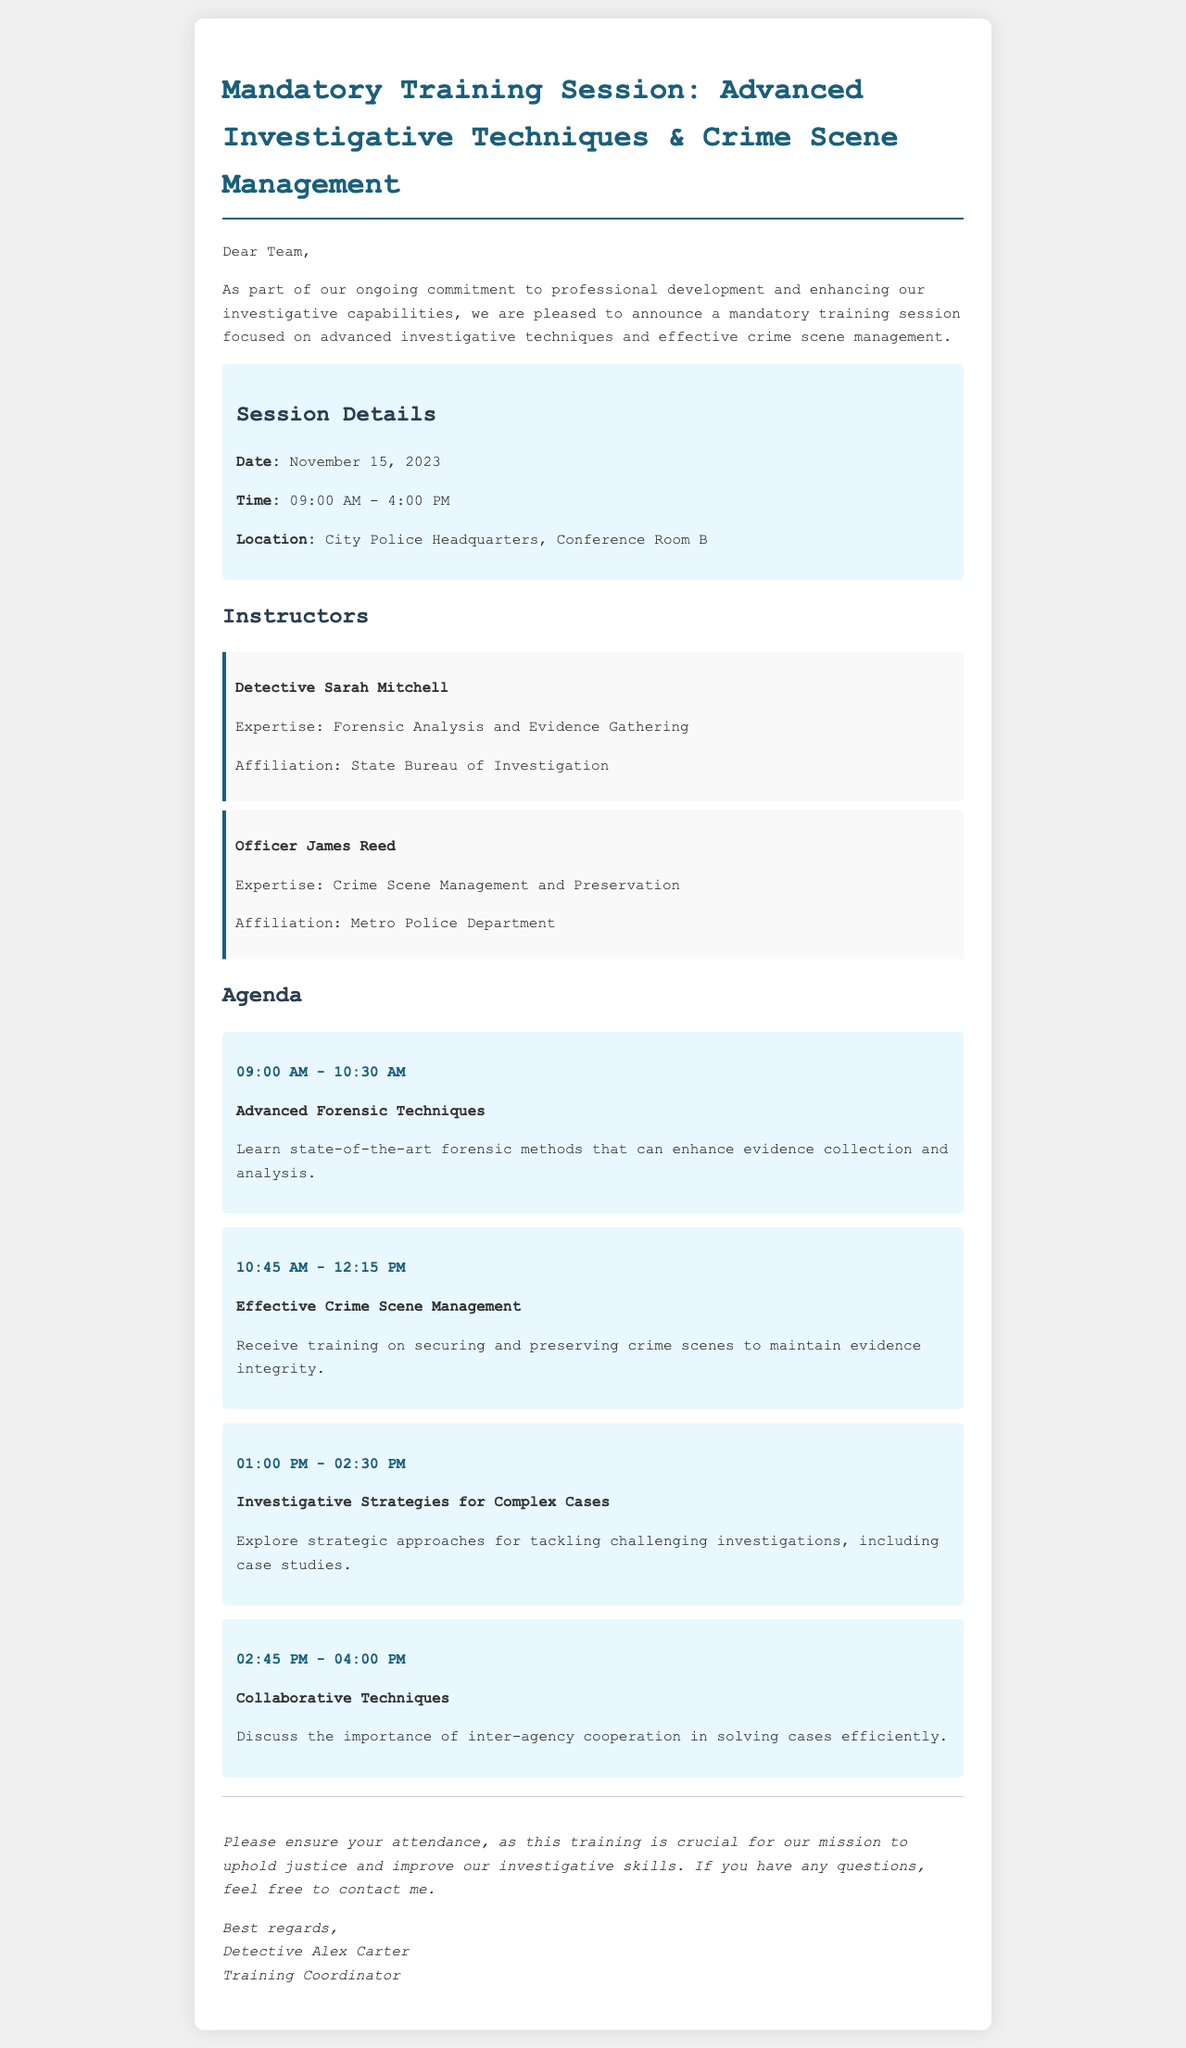What is the date of the training session? The date is mentioned in the session details section of the document.
Answer: November 15, 2023 What is the location of the training session? The location is specified in the session details section.
Answer: City Police Headquarters, Conference Room B Who is one of the instructors for the session? The instructors are listed under the Instructors section, requiring retrieval of a name.
Answer: Detective Sarah Mitchell What is the first topic on the agenda? The agenda lists the topics, and the first item is what we need to identify.
Answer: Advanced Forensic Techniques How long is the training session scheduled to last? The time is provided in the session details, indicating the duration of the training.
Answer: 7 hours What will participants learn during the 01:00 PM - 02:30 PM session? This requires understanding the agenda timing and correlating to the respective learning topic.
Answer: Investigative Strategies for Complex Cases How should attendees communicate their questions? The document specifically mentions how inquiries should be handled, regarding communication.
Answer: Contact me What is the purpose of this training session? The overall aim is discussed in the opening paragraph, summarizing the document’s intent.
Answer: Enhance investigative capabilities 